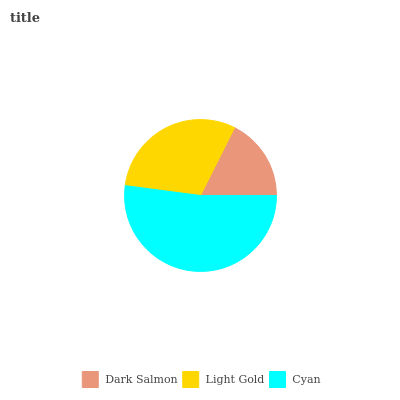Is Dark Salmon the minimum?
Answer yes or no. Yes. Is Cyan the maximum?
Answer yes or no. Yes. Is Light Gold the minimum?
Answer yes or no. No. Is Light Gold the maximum?
Answer yes or no. No. Is Light Gold greater than Dark Salmon?
Answer yes or no. Yes. Is Dark Salmon less than Light Gold?
Answer yes or no. Yes. Is Dark Salmon greater than Light Gold?
Answer yes or no. No. Is Light Gold less than Dark Salmon?
Answer yes or no. No. Is Light Gold the high median?
Answer yes or no. Yes. Is Light Gold the low median?
Answer yes or no. Yes. Is Cyan the high median?
Answer yes or no. No. Is Cyan the low median?
Answer yes or no. No. 